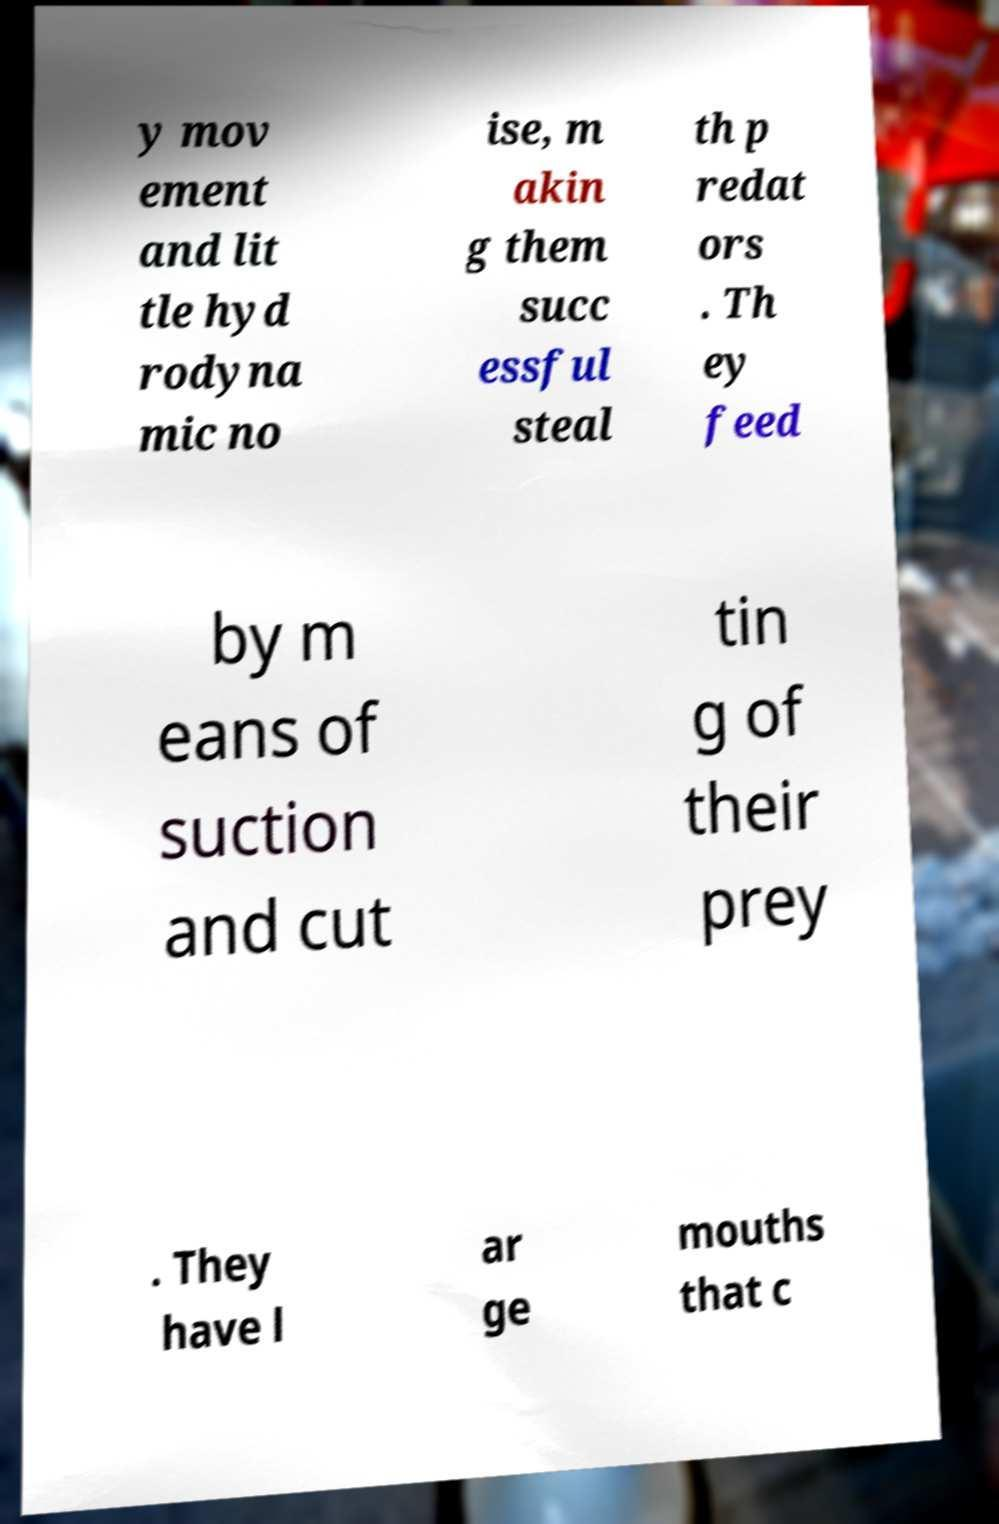Can you accurately transcribe the text from the provided image for me? y mov ement and lit tle hyd rodyna mic no ise, m akin g them succ essful steal th p redat ors . Th ey feed by m eans of suction and cut tin g of their prey . They have l ar ge mouths that c 